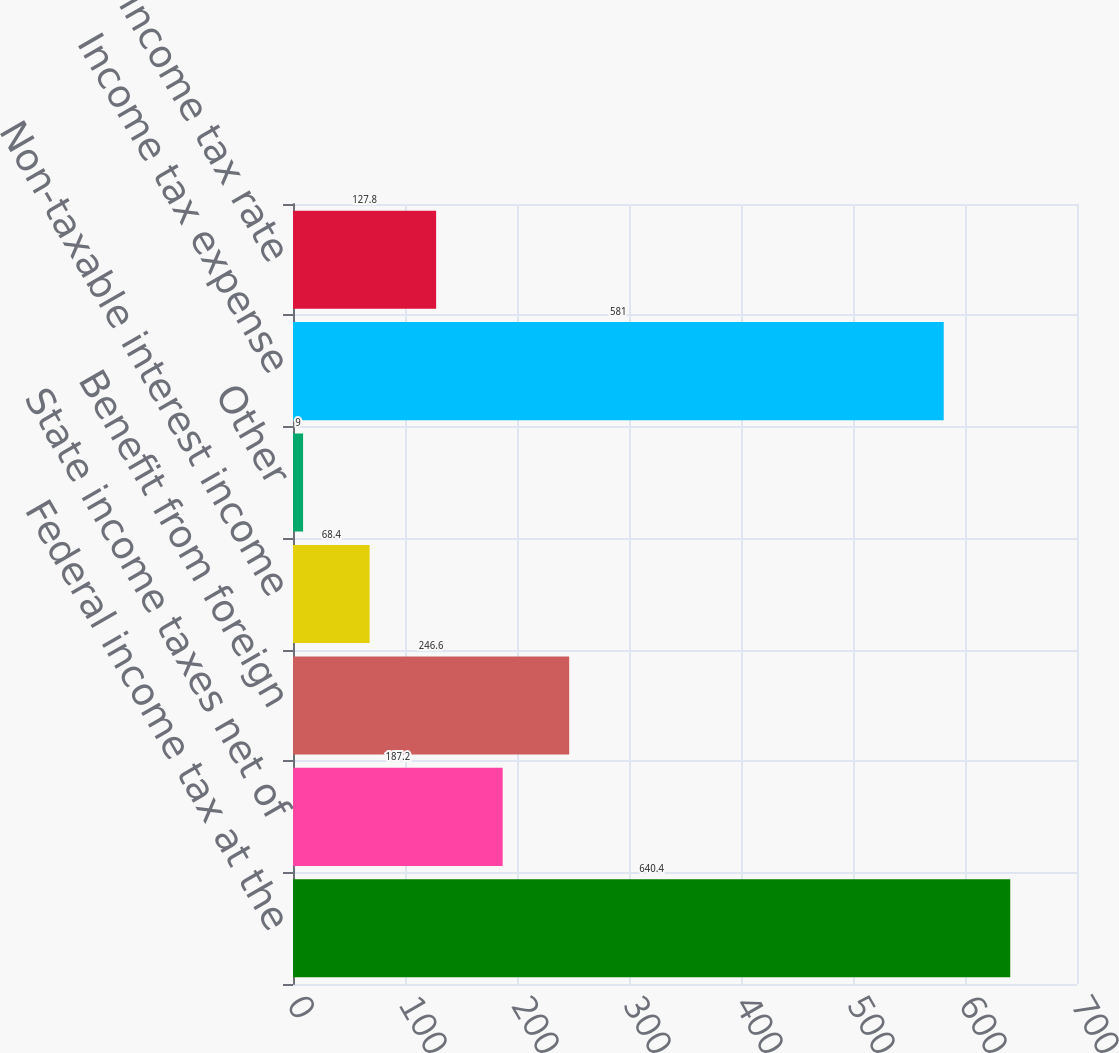Convert chart. <chart><loc_0><loc_0><loc_500><loc_500><bar_chart><fcel>Federal income tax at the<fcel>State income taxes net of<fcel>Benefit from foreign<fcel>Non-taxable interest income<fcel>Other<fcel>Income tax expense<fcel>Effective income tax rate<nl><fcel>640.4<fcel>187.2<fcel>246.6<fcel>68.4<fcel>9<fcel>581<fcel>127.8<nl></chart> 